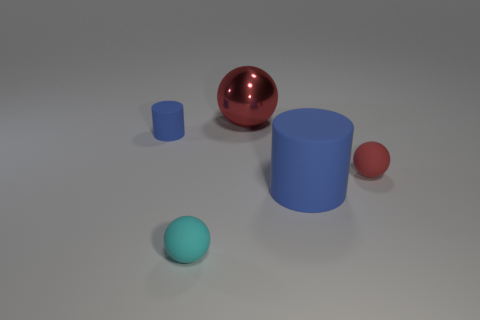Subtract 1 balls. How many balls are left? 2 Subtract all cyan balls. How many balls are left? 2 Subtract all metal spheres. How many spheres are left? 2 Add 5 small matte things. How many small matte things exist? 8 Add 2 big blue rubber objects. How many objects exist? 7 Subtract 0 cyan blocks. How many objects are left? 5 Subtract all balls. How many objects are left? 2 Subtract all green balls. Subtract all green cylinders. How many balls are left? 3 Subtract all brown balls. How many green cylinders are left? 0 Subtract all small blue matte cubes. Subtract all small red objects. How many objects are left? 4 